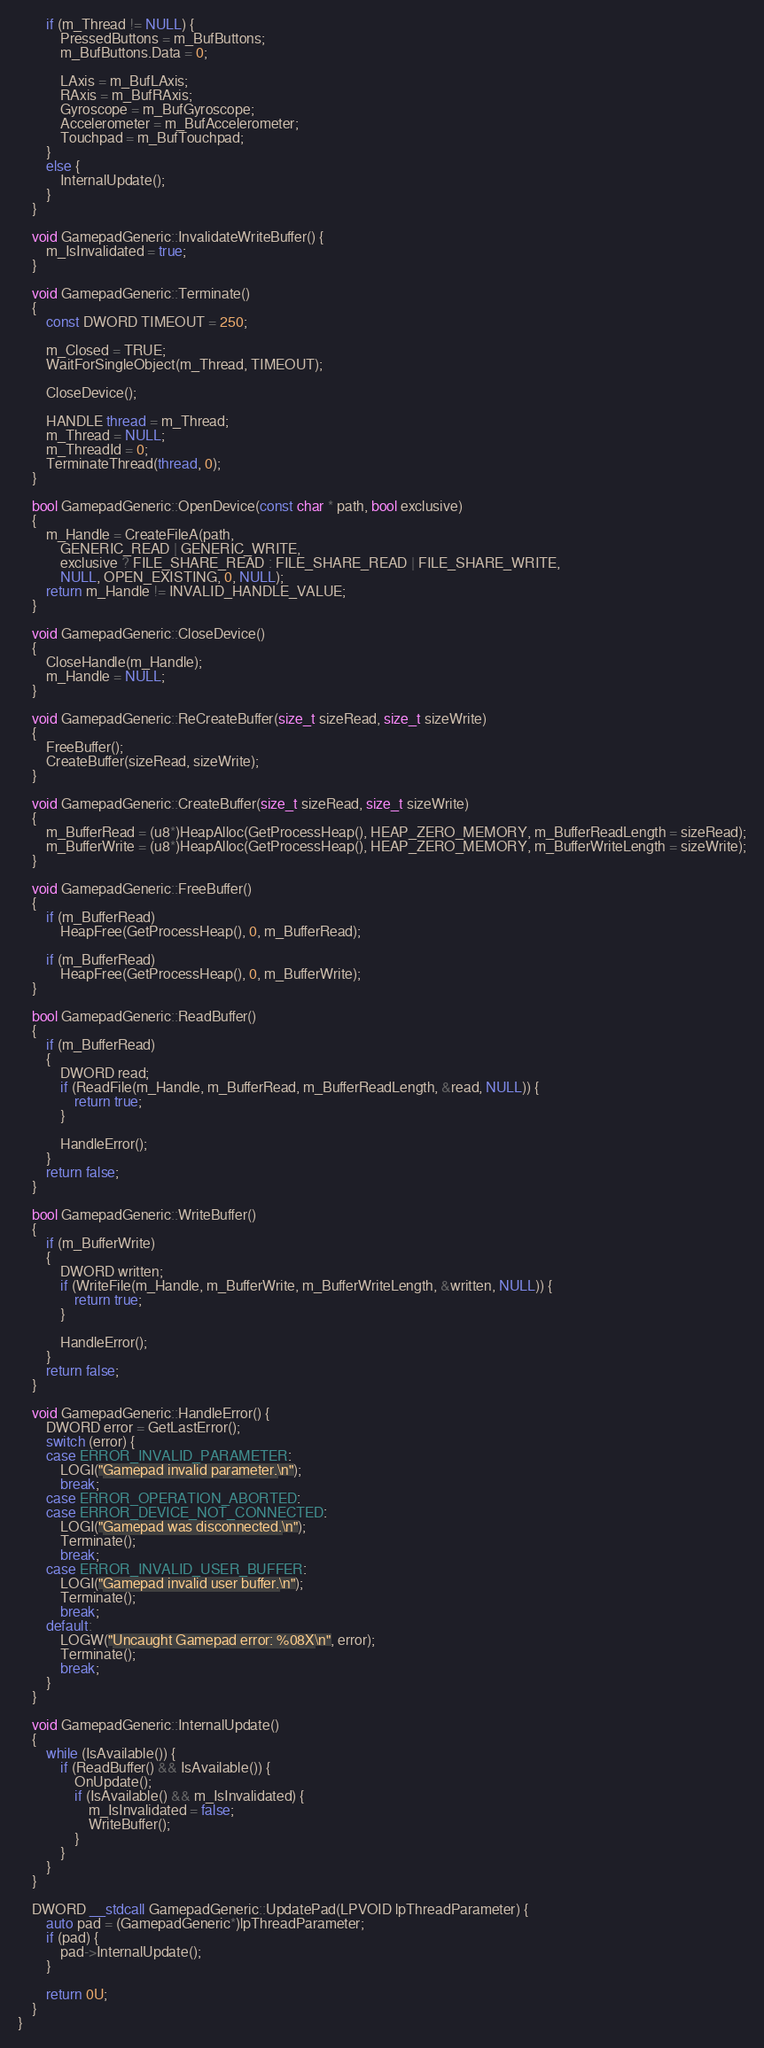<code> <loc_0><loc_0><loc_500><loc_500><_C++_>		if (m_Thread != NULL) {
			PressedButtons = m_BufButtons;
			m_BufButtons.Data = 0;

			LAxis = m_BufLAxis;
			RAxis = m_BufRAxis;
			Gyroscope = m_BufGyroscope;
			Accelerometer = m_BufAccelerometer;
			Touchpad = m_BufTouchpad;
		}
		else {
			InternalUpdate();
		}
	}

	void GamepadGeneric::InvalidateWriteBuffer() {
		m_IsInvalidated = true;
	}

	void GamepadGeneric::Terminate()
	{
		const DWORD TIMEOUT = 250;

		m_Closed = TRUE;
		WaitForSingleObject(m_Thread, TIMEOUT);

		CloseDevice();

		HANDLE thread = m_Thread;
		m_Thread = NULL;
		m_ThreadId = 0;
		TerminateThread(thread, 0);
	}

	bool GamepadGeneric::OpenDevice(const char * path, bool exclusive)
	{
		m_Handle = CreateFileA(path,
			GENERIC_READ | GENERIC_WRITE,
			exclusive ? FILE_SHARE_READ : FILE_SHARE_READ | FILE_SHARE_WRITE,
			NULL, OPEN_EXISTING, 0, NULL);
		return m_Handle != INVALID_HANDLE_VALUE;
	}

	void GamepadGeneric::CloseDevice()
	{
		CloseHandle(m_Handle);
		m_Handle = NULL;
	}

	void GamepadGeneric::ReCreateBuffer(size_t sizeRead, size_t sizeWrite)
	{
		FreeBuffer();
		CreateBuffer(sizeRead, sizeWrite);
	}

	void GamepadGeneric::CreateBuffer(size_t sizeRead, size_t sizeWrite)
	{
		m_BufferRead = (u8*)HeapAlloc(GetProcessHeap(), HEAP_ZERO_MEMORY, m_BufferReadLength = sizeRead);
		m_BufferWrite = (u8*)HeapAlloc(GetProcessHeap(), HEAP_ZERO_MEMORY, m_BufferWriteLength = sizeWrite);
	}

	void GamepadGeneric::FreeBuffer()
	{
		if (m_BufferRead)
			HeapFree(GetProcessHeap(), 0, m_BufferRead);

		if (m_BufferRead)
			HeapFree(GetProcessHeap(), 0, m_BufferWrite);
	}

	bool GamepadGeneric::ReadBuffer()
	{
		if (m_BufferRead)
		{		
			DWORD read;
			if (ReadFile(m_Handle, m_BufferRead, m_BufferReadLength, &read, NULL)) {
				return true;
			}

			HandleError();
		}
		return false;
	}

	bool GamepadGeneric::WriteBuffer()
	{
		if (m_BufferWrite)
		{
			DWORD written;
			if (WriteFile(m_Handle, m_BufferWrite, m_BufferWriteLength, &written, NULL)) {
				return true;
			}

			HandleError();
		}
		return false;
	}

	void GamepadGeneric::HandleError() {
		DWORD error = GetLastError();
		switch (error) {
		case ERROR_INVALID_PARAMETER:
			LOGI("Gamepad invalid parameter.\n");
			break;
		case ERROR_OPERATION_ABORTED:
		case ERROR_DEVICE_NOT_CONNECTED:
			LOGI("Gamepad was disconnected.\n");
			Terminate();
			break;
		case ERROR_INVALID_USER_BUFFER:
			LOGI("Gamepad invalid user buffer.\n");
			Terminate();
			break;
		default:
			LOGW("Uncaught Gamepad error: %08X\n", error);
			Terminate();
			break;
		}
	}

	void GamepadGeneric::InternalUpdate()
	{
		while (IsAvailable()) {
			if (ReadBuffer() && IsAvailable()) {
				OnUpdate();
				if (IsAvailable() && m_IsInvalidated) {
					m_IsInvalidated = false;
					WriteBuffer();
				}
			}
		}
	}

	DWORD __stdcall GamepadGeneric::UpdatePad(LPVOID lpThreadParameter) {
		auto pad = (GamepadGeneric*)lpThreadParameter;
		if (pad) {
			pad->InternalUpdate();
		}

		return 0U;
	}
}</code> 